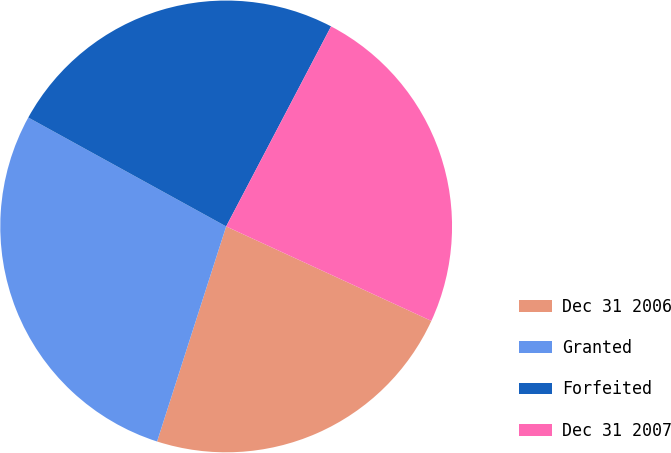<chart> <loc_0><loc_0><loc_500><loc_500><pie_chart><fcel>Dec 31 2006<fcel>Granted<fcel>Forfeited<fcel>Dec 31 2007<nl><fcel>23.08%<fcel>28.06%<fcel>24.68%<fcel>24.18%<nl></chart> 